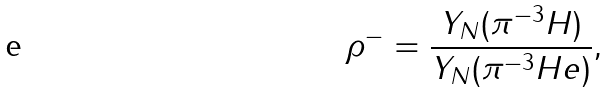Convert formula to latex. <formula><loc_0><loc_0><loc_500><loc_500>\rho ^ { - } = \frac { Y _ { N } ( \pi ^ { - 3 } H ) } { Y _ { N } ( \pi ^ { - 3 } H e ) } ,</formula> 